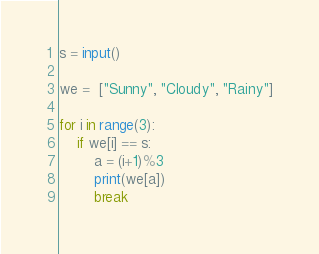Convert code to text. <code><loc_0><loc_0><loc_500><loc_500><_Python_>s = input()

we =  ["Sunny", "Cloudy", "Rainy"]

for i in range(3):
    if we[i] == s:
        a = (i+1)%3
        print(we[a])
        break
</code> 